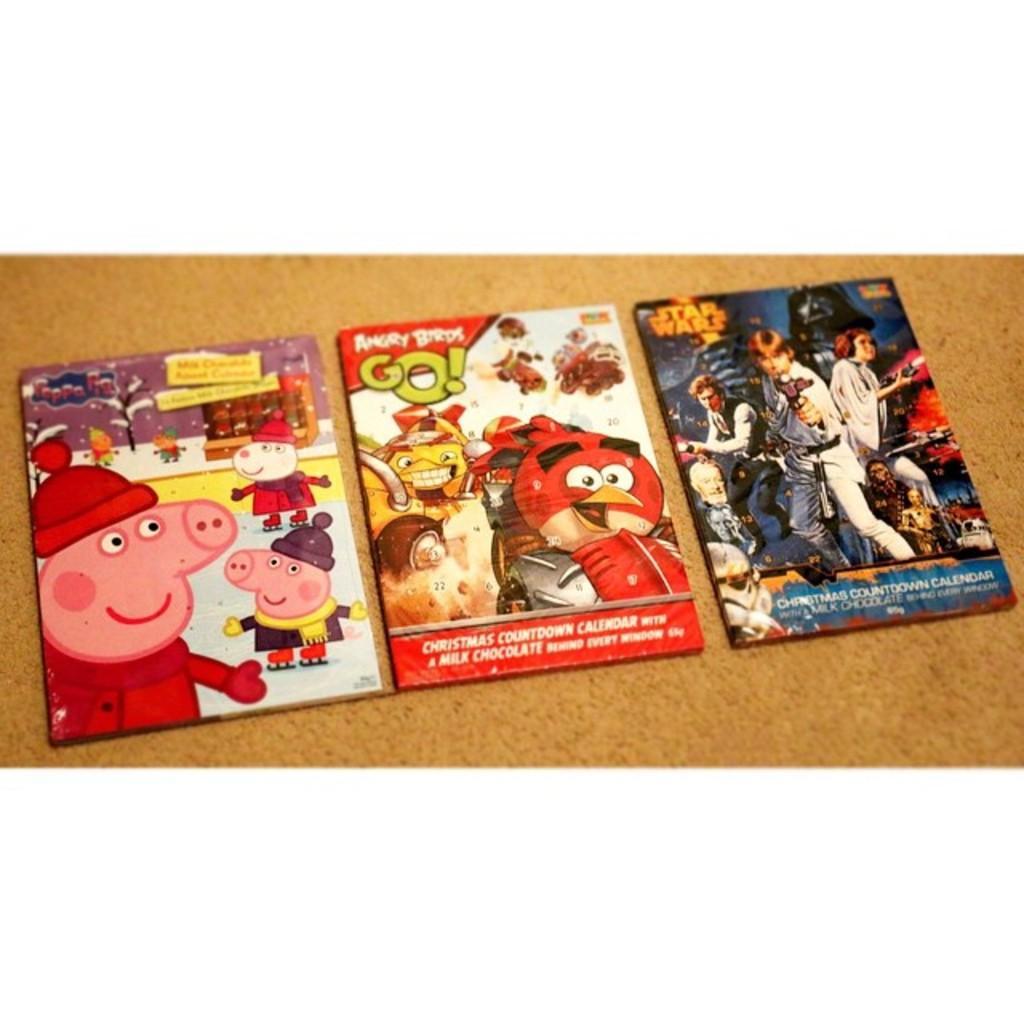In one or two sentences, can you explain what this image depicts? In this picture, I can see few cartoon pictures on the floor and a white color carpet on the floor. 